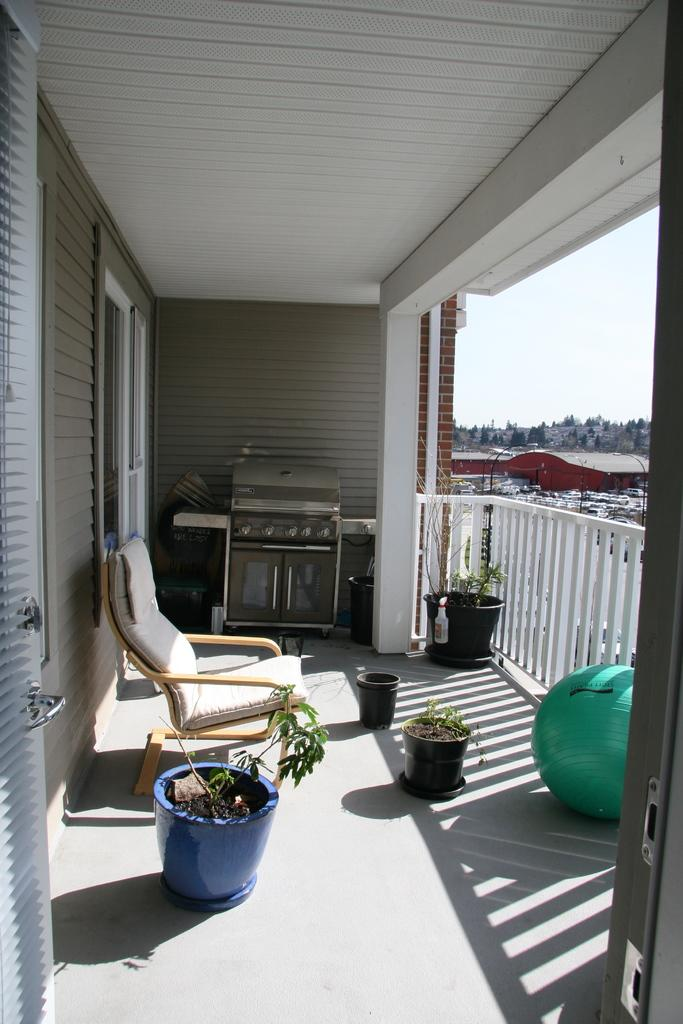What type of outdoor space is shown in the image? The image depicts a balcony. What furniture is present on the balcony? There is a chair on the balcony. Are there any decorative elements on the balcony? Yes, there is a flower pot on the balcony. What is growing in the flower pot? A plant is present in the flower pot. What other object can be seen on the balcony? There is an air ball on the balcony. What can be seen in the background of the image? The sky and trees are visible in the image. Can you tell me how many caves are visible from the balcony in the image? There are no caves visible from the balcony in the image. What type of soda is being served on the balcony in the image? There is no soda present in the image; it only shows a chair, flower pot, plant, air ball, and the sky and trees in the background. 